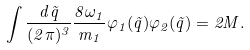<formula> <loc_0><loc_0><loc_500><loc_500>\int \frac { d { \vec { q } } } { ( 2 \pi ) ^ { 3 } } \frac { 8 \omega _ { 1 } } { m _ { 1 } } \varphi _ { 1 } ( { \vec { q } } ) \varphi _ { 2 } ( { \vec { q } } ) = 2 M .</formula> 